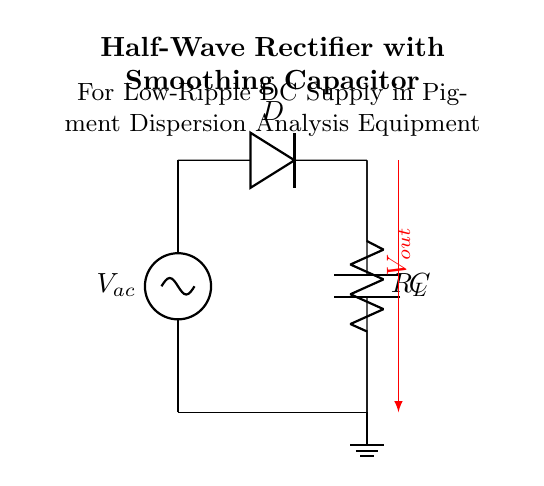What type of diode is used in this circuit? The circuit diagram indicates a generic diode symbol labeled as "D," which represents a standard diode used for rectification in the circuit.
Answer: diode What is the purpose of the capacitor in this circuit? The capacitor labeled "C" is used for smoothing the output voltage, reducing ripple in the rectified DC supply, which is essential for stable operation in pigment dispersion analysis equipment.
Answer: smoothing What is the load resistor in the circuit? The load resistor is labeled as "R_L," indicating it is connected across the output of the rectifier and is responsible for dissipating energy and determining the output load for the circuit.
Answer: R_L How many diodes are present in this circuit? From the circuit diagram, only one diode is visible, which is sufficient for a half-wave rectifier setup since it only allows one half of the AC waveform to pass through.
Answer: one What is the type of rectifier represented by this circuit? The circuit is a half-wave rectifier, which is characterized by its ability to rectify only one half of the AC signal, resulting in a pulsating DC output.
Answer: half-wave What effect does the smoothing capacitor have on output voltage? The smoothing capacitor helps to charge during the peak of the rectified voltage and discharges during the drop, thus reducing fluctuations and providing a more stable average output voltage.
Answer: reduces ripple What is the output voltage in relation to the input AC voltage? The output voltage is less than the peak input AC voltage since the diode introduces a forward voltage drop, and the smoothing capacitor's discharge also influences it.
Answer: less than peak 